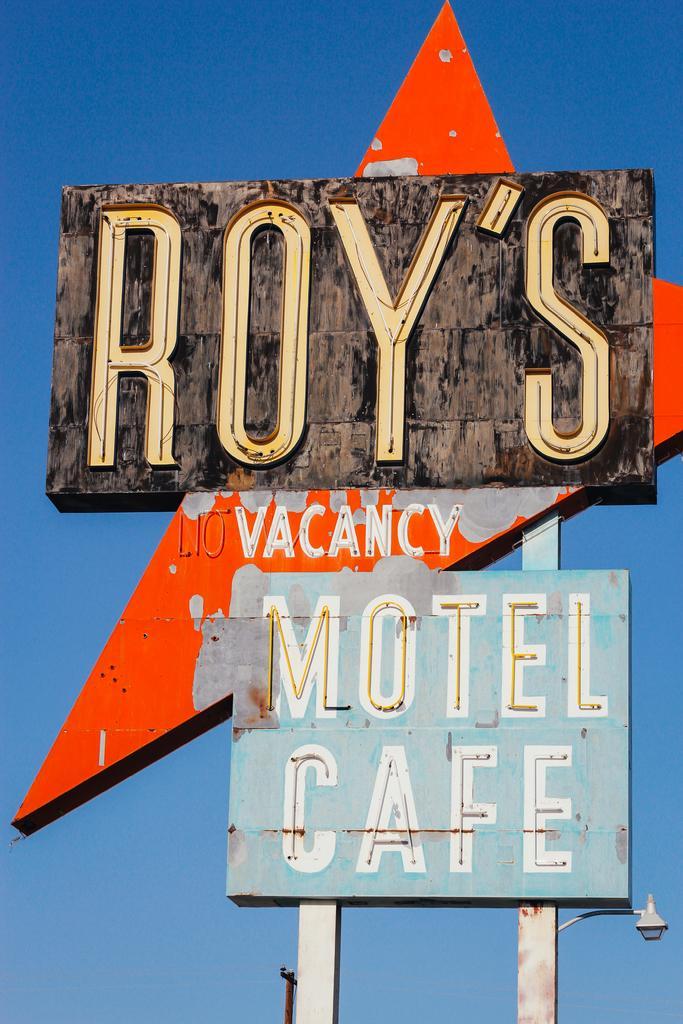Describe this image in one or two sentences. In this picture I can see a board with some text and I can see light and a blue sky in the back. 